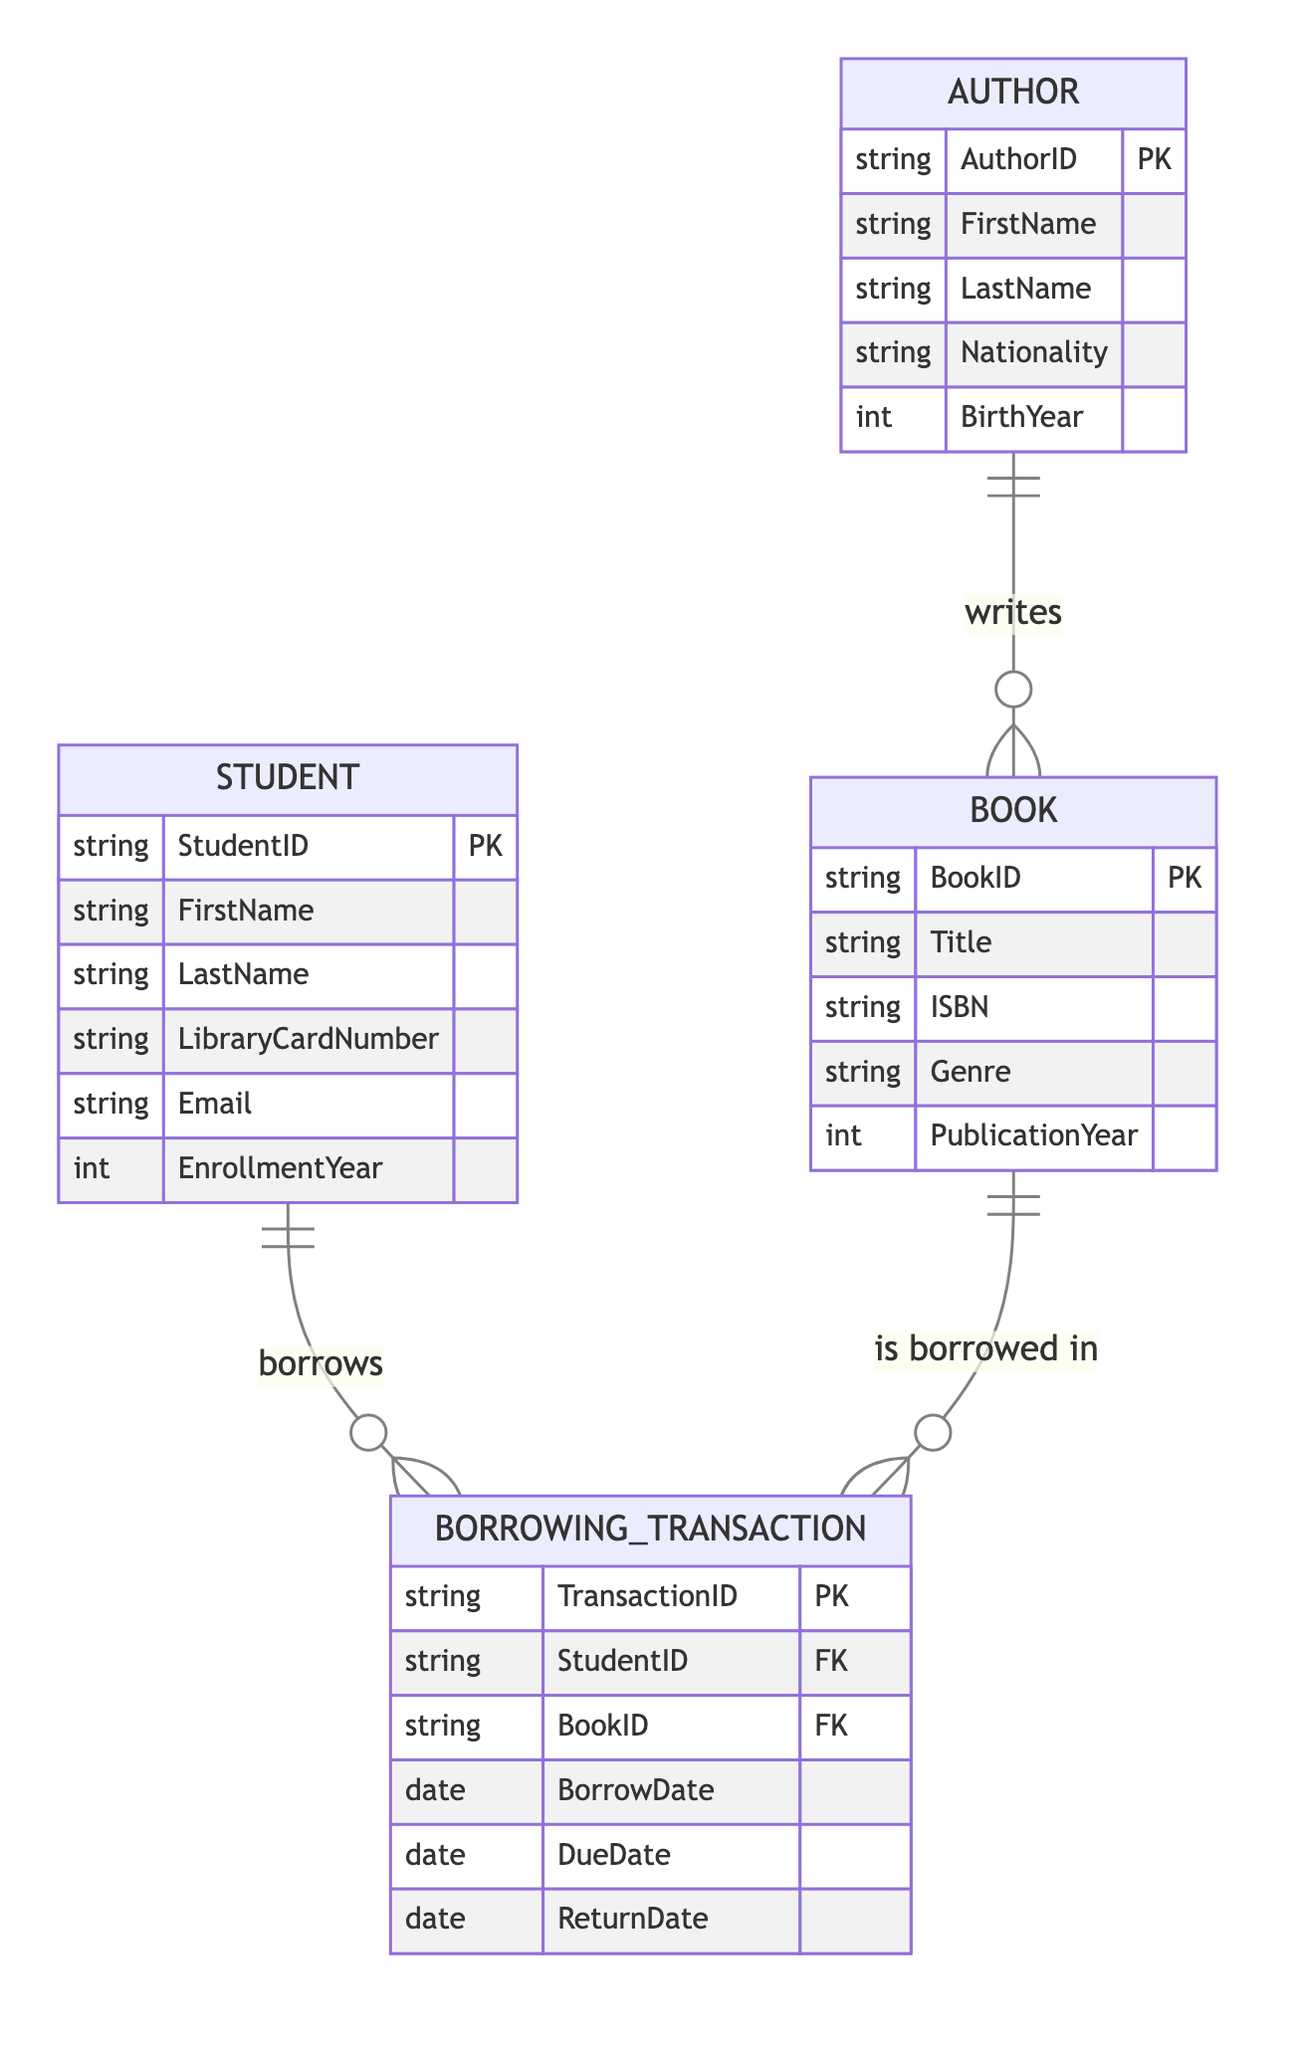What is the primary key of the Student entity? The primary key for the Student entity is StudentID, as indicated by the PK designation next to it in the diagram.
Answer: StudentID How many entities are present in the diagram? The diagram features four entities: Student, Book, Author, and Borrowing Transaction. Therefore, the total count is four.
Answer: Four What relationship connects Student and Borrowing Transaction? The relationship between the Student and Borrowing Transaction entities is labeled "borrows," indicating that students can borrow books through these transactions.
Answer: borrows What attribute is used to track the return date of borrowed items? The ReturnDate attribute in the Borrowing Transaction entity is used to record when a borrowed book is returned.
Answer: ReturnDate How many attributes does the Book entity have? The Book entity has five attributes: BookID, Title, ISBN, Genre, and PublicationYear, making the total count five.
Answer: Five Which entity can have multiple associated records in Borrowing Transactions? The Student entity can have multiple Borrowing Transactions since a single student can borrow multiple books over time, indicating a one-to-many relationship.
Answer: Student What is the foreign key in the Borrowing Transaction entity? The foreign keys in the Borrowing Transaction entity are StudentID and BookID, which link this transaction to the corresponding student and book, respectively.
Answer: StudentID, BookID Which attributes identify an Author? AuthorID serves as the primary key, while FirstName and LastName are attributes that provide personal identification for the author.
Answer: AuthorID, FirstName, LastName What connects an Author to a Book? The relationship labeled "writes" connects an Author to a Book, indicating that authors write books, forming a fundamental connection between the two entities.
Answer: writes 